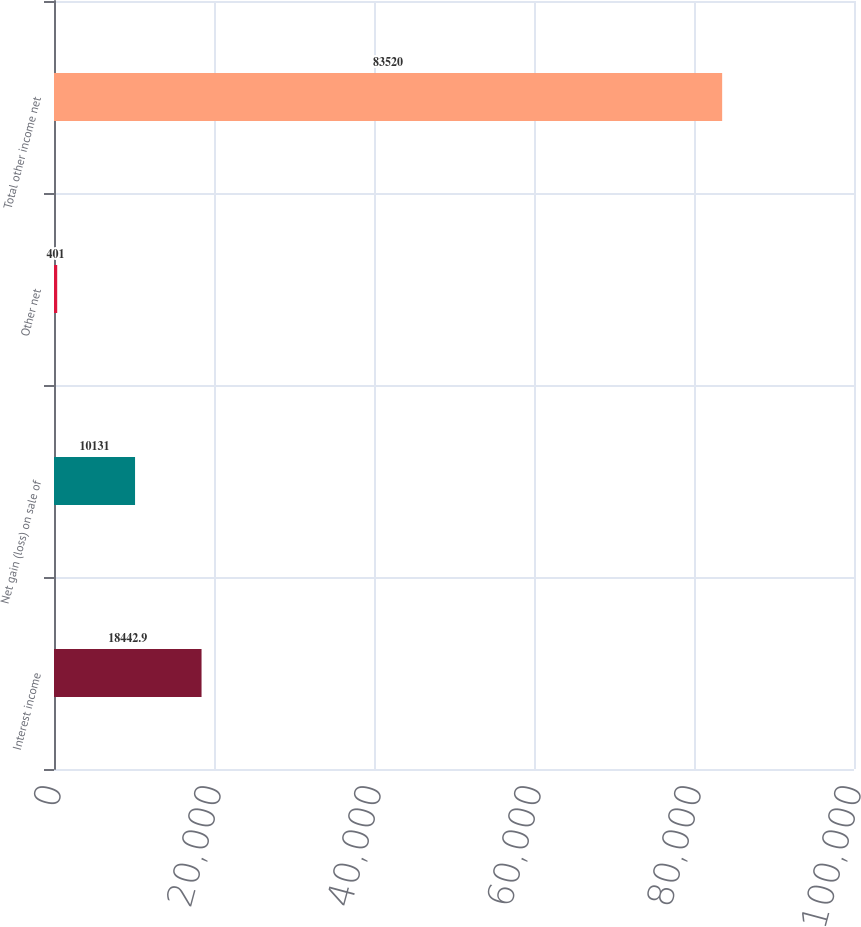<chart> <loc_0><loc_0><loc_500><loc_500><bar_chart><fcel>Interest income<fcel>Net gain (loss) on sale of<fcel>Other net<fcel>Total other income net<nl><fcel>18442.9<fcel>10131<fcel>401<fcel>83520<nl></chart> 